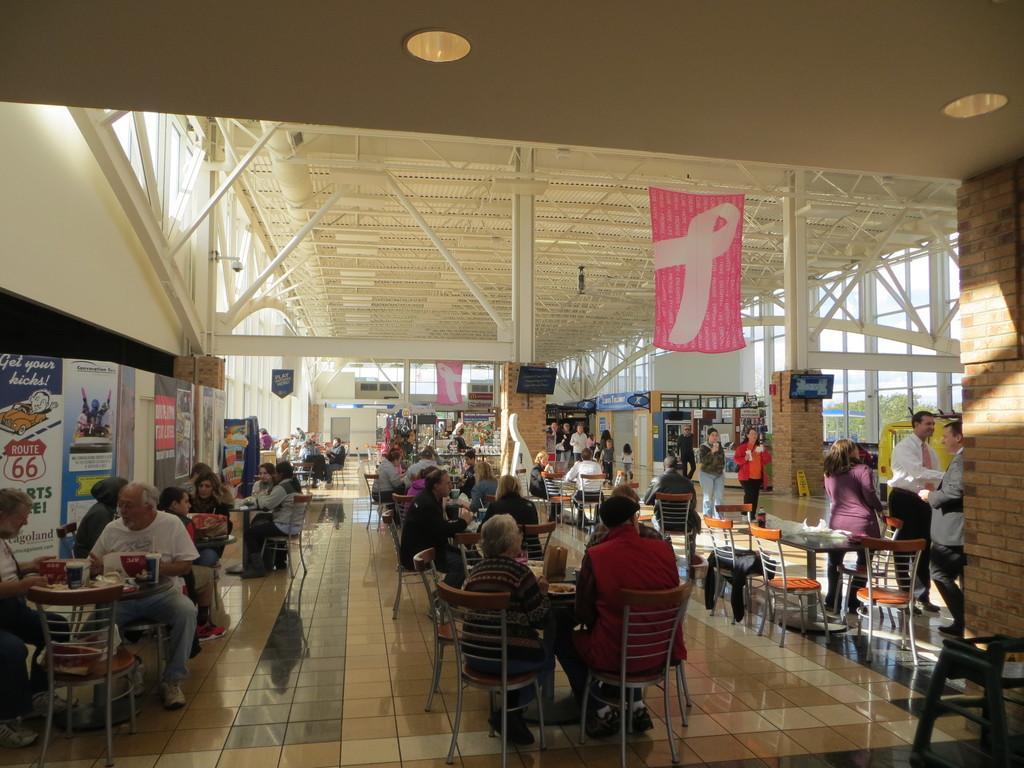Describe this image in one or two sentences. There are few people here sitting on the chair at the table. On the table we can see food items. On the right there are few people standing. In the background we can see poles,door,TV,window. Through window we can see trees. Here in the middle there is a banner hanging. 